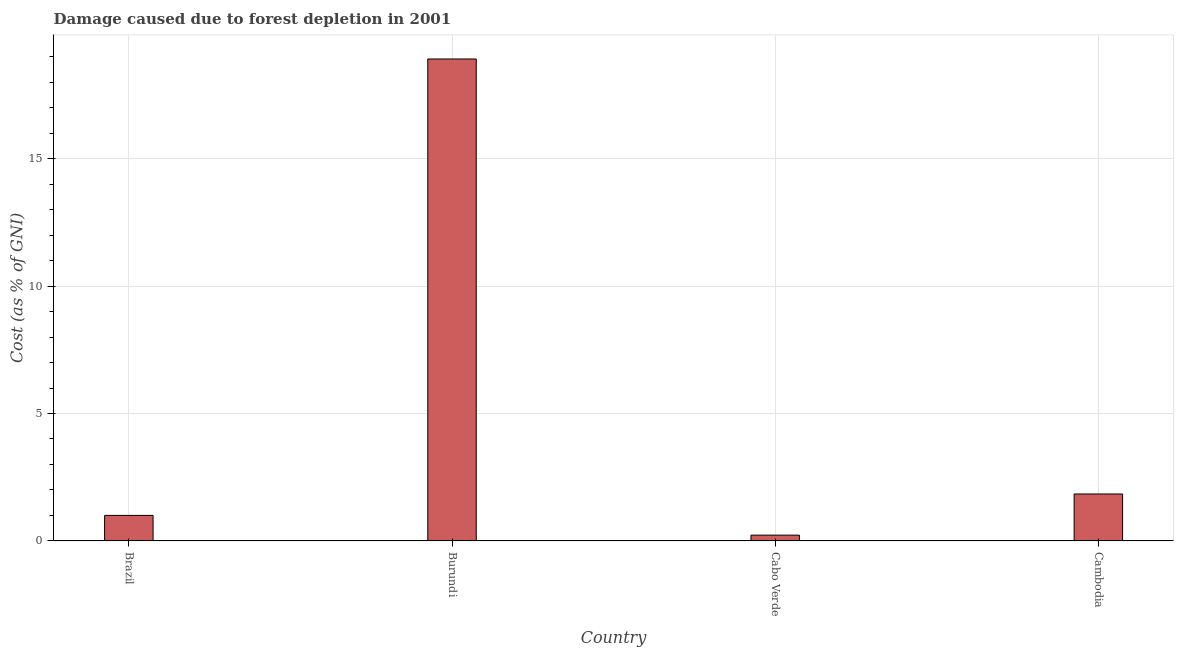Does the graph contain any zero values?
Your answer should be very brief. No. Does the graph contain grids?
Offer a very short reply. Yes. What is the title of the graph?
Ensure brevity in your answer.  Damage caused due to forest depletion in 2001. What is the label or title of the Y-axis?
Make the answer very short. Cost (as % of GNI). What is the damage caused due to forest depletion in Brazil?
Give a very brief answer. 1. Across all countries, what is the maximum damage caused due to forest depletion?
Provide a succinct answer. 18.91. Across all countries, what is the minimum damage caused due to forest depletion?
Ensure brevity in your answer.  0.23. In which country was the damage caused due to forest depletion maximum?
Provide a short and direct response. Burundi. In which country was the damage caused due to forest depletion minimum?
Offer a terse response. Cabo Verde. What is the sum of the damage caused due to forest depletion?
Your answer should be compact. 21.98. What is the difference between the damage caused due to forest depletion in Brazil and Burundi?
Provide a short and direct response. -17.91. What is the average damage caused due to forest depletion per country?
Give a very brief answer. 5.5. What is the median damage caused due to forest depletion?
Your answer should be compact. 1.42. What is the ratio of the damage caused due to forest depletion in Brazil to that in Cambodia?
Provide a succinct answer. 0.54. What is the difference between the highest and the second highest damage caused due to forest depletion?
Provide a succinct answer. 17.07. Is the sum of the damage caused due to forest depletion in Cabo Verde and Cambodia greater than the maximum damage caused due to forest depletion across all countries?
Offer a terse response. No. What is the difference between the highest and the lowest damage caused due to forest depletion?
Make the answer very short. 18.68. Are all the bars in the graph horizontal?
Make the answer very short. No. How many countries are there in the graph?
Keep it short and to the point. 4. What is the difference between two consecutive major ticks on the Y-axis?
Your answer should be very brief. 5. Are the values on the major ticks of Y-axis written in scientific E-notation?
Give a very brief answer. No. What is the Cost (as % of GNI) in Brazil?
Your response must be concise. 1. What is the Cost (as % of GNI) in Burundi?
Offer a terse response. 18.91. What is the Cost (as % of GNI) of Cabo Verde?
Your answer should be very brief. 0.23. What is the Cost (as % of GNI) of Cambodia?
Your answer should be very brief. 1.84. What is the difference between the Cost (as % of GNI) in Brazil and Burundi?
Provide a succinct answer. -17.91. What is the difference between the Cost (as % of GNI) in Brazil and Cabo Verde?
Your answer should be very brief. 0.77. What is the difference between the Cost (as % of GNI) in Brazil and Cambodia?
Offer a terse response. -0.84. What is the difference between the Cost (as % of GNI) in Burundi and Cabo Verde?
Ensure brevity in your answer.  18.68. What is the difference between the Cost (as % of GNI) in Burundi and Cambodia?
Provide a short and direct response. 17.07. What is the difference between the Cost (as % of GNI) in Cabo Verde and Cambodia?
Provide a short and direct response. -1.61. What is the ratio of the Cost (as % of GNI) in Brazil to that in Burundi?
Offer a terse response. 0.05. What is the ratio of the Cost (as % of GNI) in Brazil to that in Cabo Verde?
Make the answer very short. 4.41. What is the ratio of the Cost (as % of GNI) in Brazil to that in Cambodia?
Your answer should be very brief. 0.54. What is the ratio of the Cost (as % of GNI) in Burundi to that in Cabo Verde?
Make the answer very short. 83.27. What is the ratio of the Cost (as % of GNI) in Burundi to that in Cambodia?
Your answer should be compact. 10.27. What is the ratio of the Cost (as % of GNI) in Cabo Verde to that in Cambodia?
Keep it short and to the point. 0.12. 